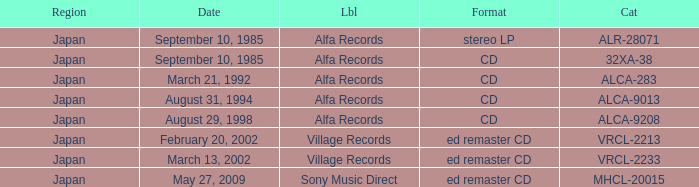Which Label was cataloged as alca-9013? Alfa Records. 